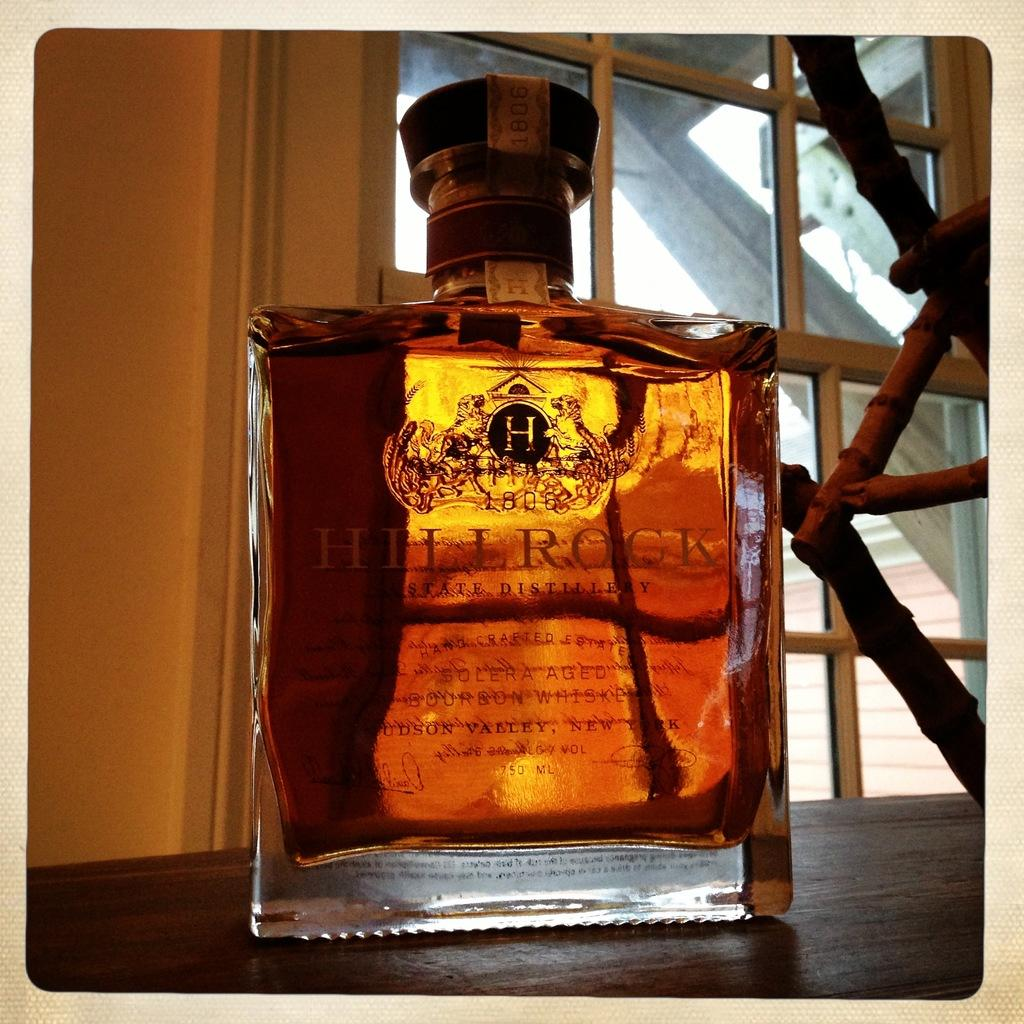<image>
Give a short and clear explanation of the subsequent image. A bottle of Hillrock whiskey is positioned in front of a window. 